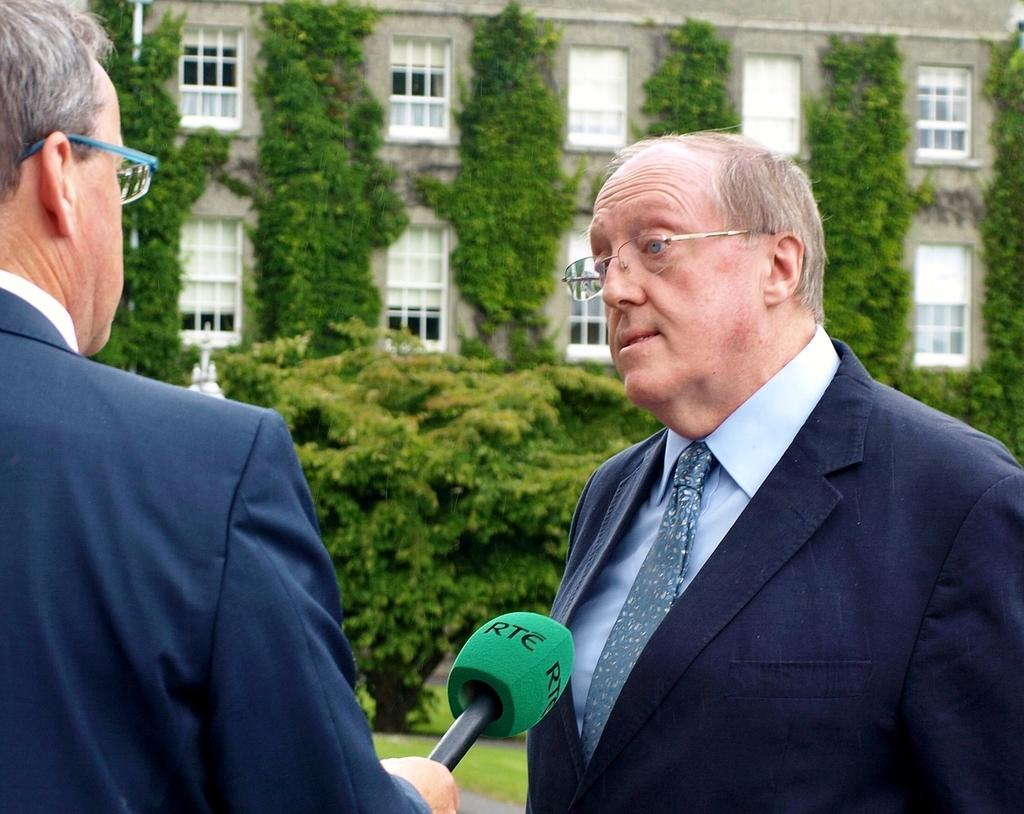How many people are in the image? There are two persons in the image. What are the people in the image doing? Both persons are standing. What can be observed about the appearance of the people in the image? Both persons are wearing spectacles. Can you describe the person holding an object in the image? One person is holding a mic. What can be seen in the background of the image? There is a building, a wall, and a tree in the background of the image. What type of glue is being used by the person holding the pen in the image? There is no glue or pen present in the image. How is the paste being applied by the person in the image? There is no paste or person applying it in the image. 